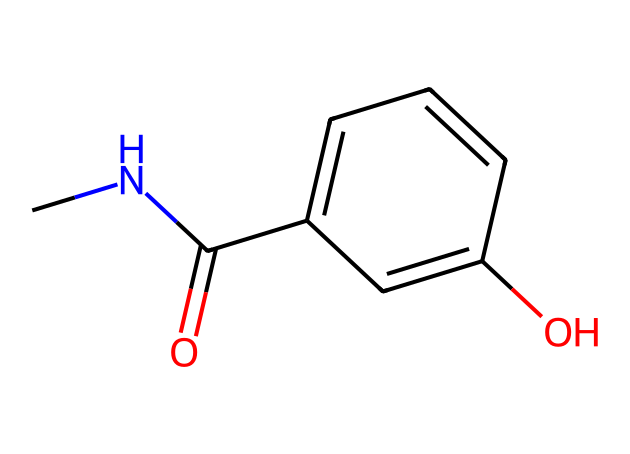What is the main functional group in this compound? The chemical structure contains a carbonyl group (C=O) as indicated by the "C(=O)" near the nitrogen and carbon atoms. Thus, the presence of this carbonyl signifies it's an amide.
Answer: amide How many rings are present in this molecule? In the SMILES representation, there is one cyclic structure indicated by "C1=CC=CC(O)=C1," meaning there is a six-membered aromatic ring present.
Answer: one What type of molecular interaction might the hydroxyl group facilitate? The hydroxyl group (-OH) can engage in hydrogen bonding due to its polarity, which can influence solubility and interactions with biological targets.
Answer: hydrogen bonding What is the total number of carbon atoms in this structure? Counting the carbon atoms from the structure, there are ten carbon atoms visible in the SMILES representation, including those in the ring and chain positions.
Answer: ten Which atom is likely responsible for potential neuroactive effects in this chemical? The nitrogen atom in the structure suggests a potential role in neurotransmitter activity, as nitrogen-containing compounds often play critical roles in neurochemistry.
Answer: nitrogen Does this compound likely possess antimicrobial properties? While certain characteristics of the structure suggest the possibility of antimicrobial properties, the definitive determination would require empirical testing beyond structural analysis alone.
Answer: likely 